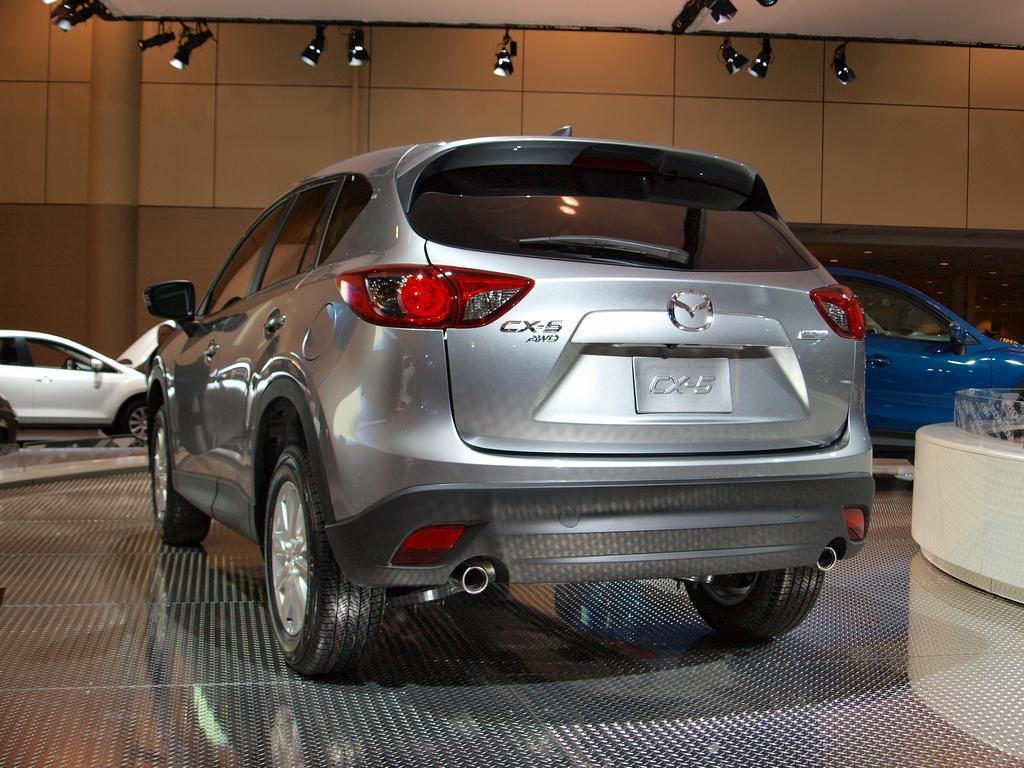How would you summarize this image in a sentence or two? This image is taken indoors. At the bottom of the image there is a floor. At the top of the image there is a ceiling and there are a few lights. In the background there is a wall and a few cars are parked on the floor. In the middle of the image a car is parked on the floor. 